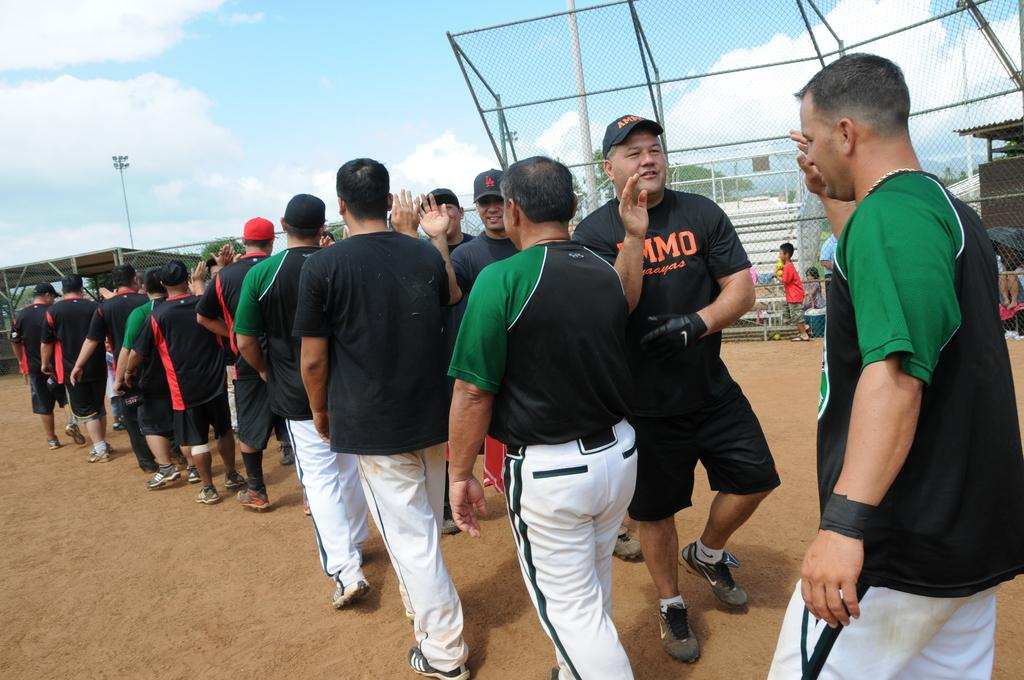<image>
Give a short and clear explanation of the subsequent image. A man wears a black shirt with the letters M, M and O visible in orange. 